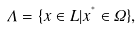Convert formula to latex. <formula><loc_0><loc_0><loc_500><loc_500>\varLambda = \{ x \in L | x ^ { ^ { * } } \in \varOmega \} ,</formula> 